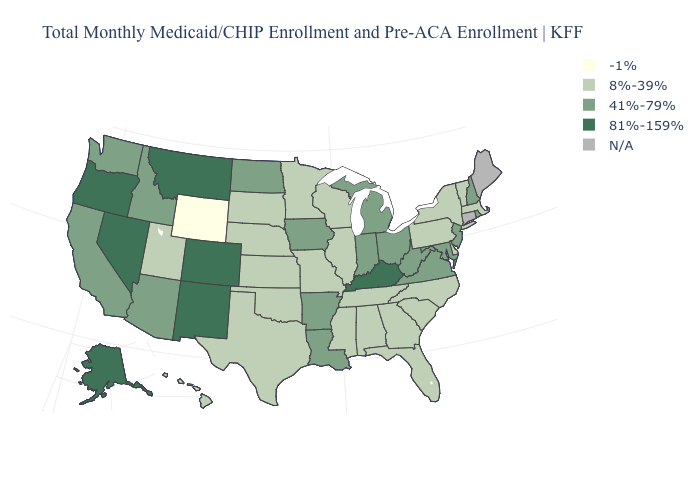Name the states that have a value in the range -1%?
Answer briefly. Wyoming. Does the first symbol in the legend represent the smallest category?
Short answer required. Yes. Does the map have missing data?
Concise answer only. Yes. Among the states that border New Mexico , which have the highest value?
Answer briefly. Colorado. What is the value of Montana?
Be succinct. 81%-159%. What is the value of Colorado?
Keep it brief. 81%-159%. What is the value of Massachusetts?
Write a very short answer. 8%-39%. What is the highest value in the West ?
Concise answer only. 81%-159%. What is the highest value in the South ?
Quick response, please. 81%-159%. What is the highest value in states that border Pennsylvania?
Short answer required. 41%-79%. Which states have the lowest value in the South?
Answer briefly. Alabama, Delaware, Florida, Georgia, Mississippi, North Carolina, Oklahoma, South Carolina, Tennessee, Texas. Does Ohio have the lowest value in the USA?
Keep it brief. No. 